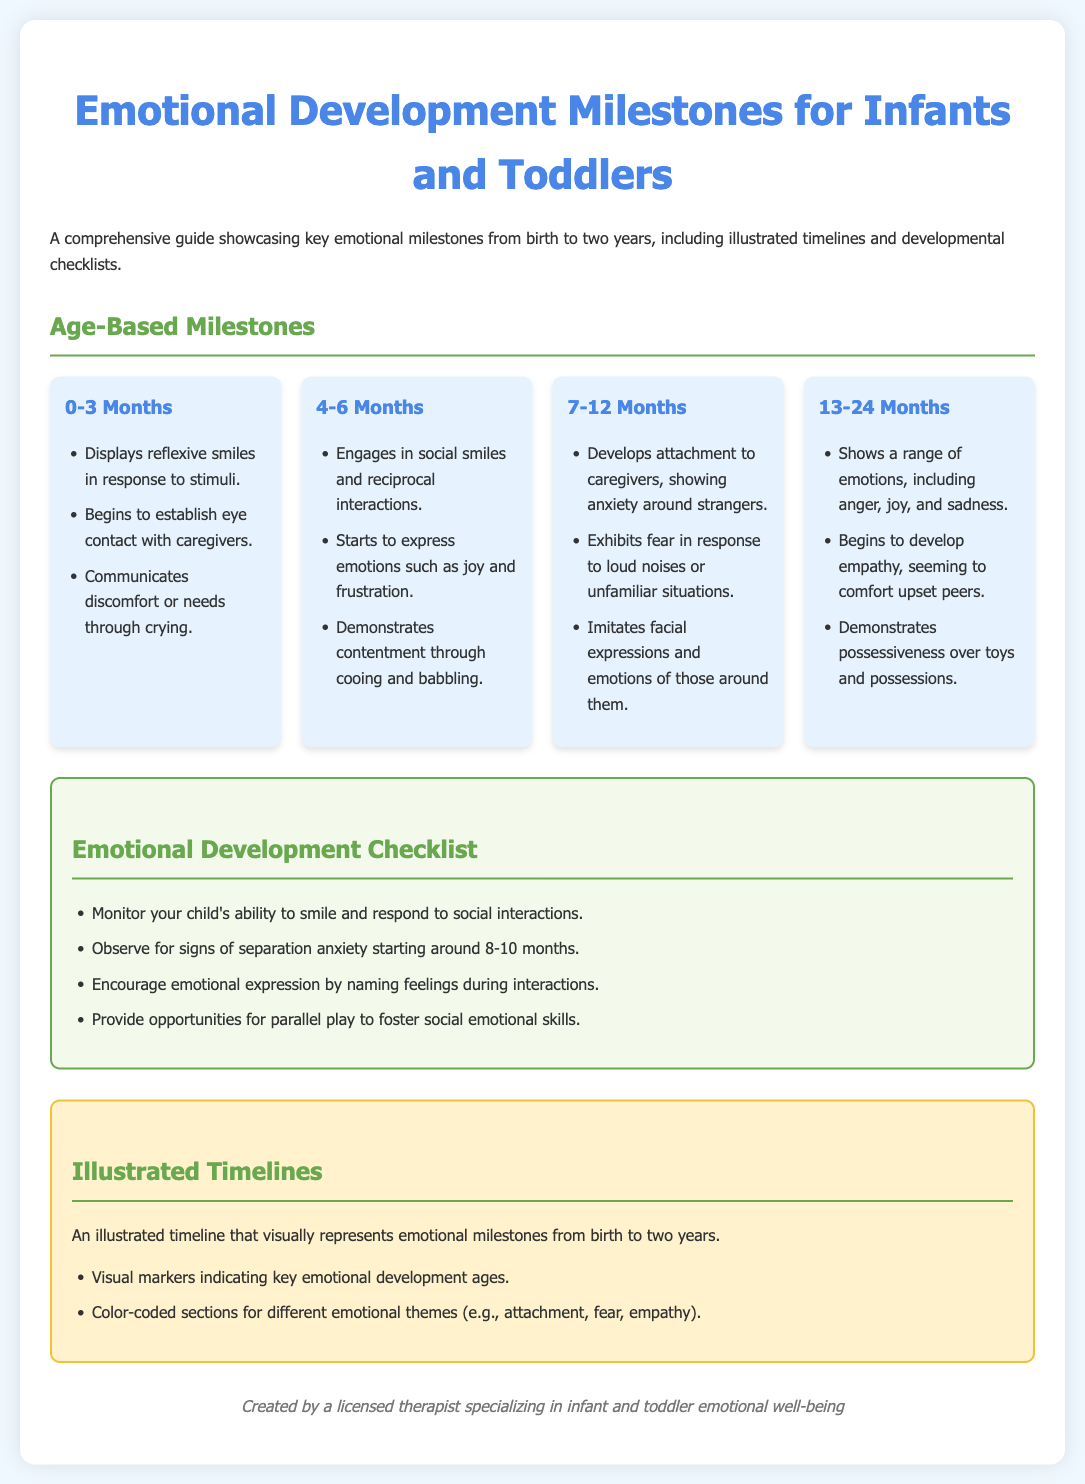What is the age range covered in the guide? The guide focuses on emotional milestones from birth to two years, which is specifically stated in the introduction.
Answer: Birth to two years What emotions do infants show by 4-6 months? Infants begin to express emotions such as joy and frustration as listed under the 4-6 months milestone.
Answer: Joy and frustration At what age do children start to develop empathy? The 13-24 months milestone mentions that children begin to develop empathy during that age range.
Answer: 13-24 months What emotional response is typically observed starting around 8-10 months? The checklist suggests monitoring for signs of separation anxiety, indicating a specific emotional response at that age.
Answer: Separation anxiety How many key emotional milestones are outlined for the 7-12 months age group? The document lists three specific milestones for the 7-12 months age group, referring to the content under that section.
Answer: Three What key activity can parents provide to foster emotional skills? The checklist emphasizes providing opportunities for parallel play to nurture social-emotional skills.
Answer: Parallel play What type of card layout is used in the milestone section? The milestone section utilizes a grid layout for visually presenting the information, as noted in the description of the section.
Answer: Grid layout What visual representation is provided for emotional milestones? An illustrated timeline is mentioned in the timeline section as a way to visually represent emotional milestones.
Answer: Illustrated timeline 